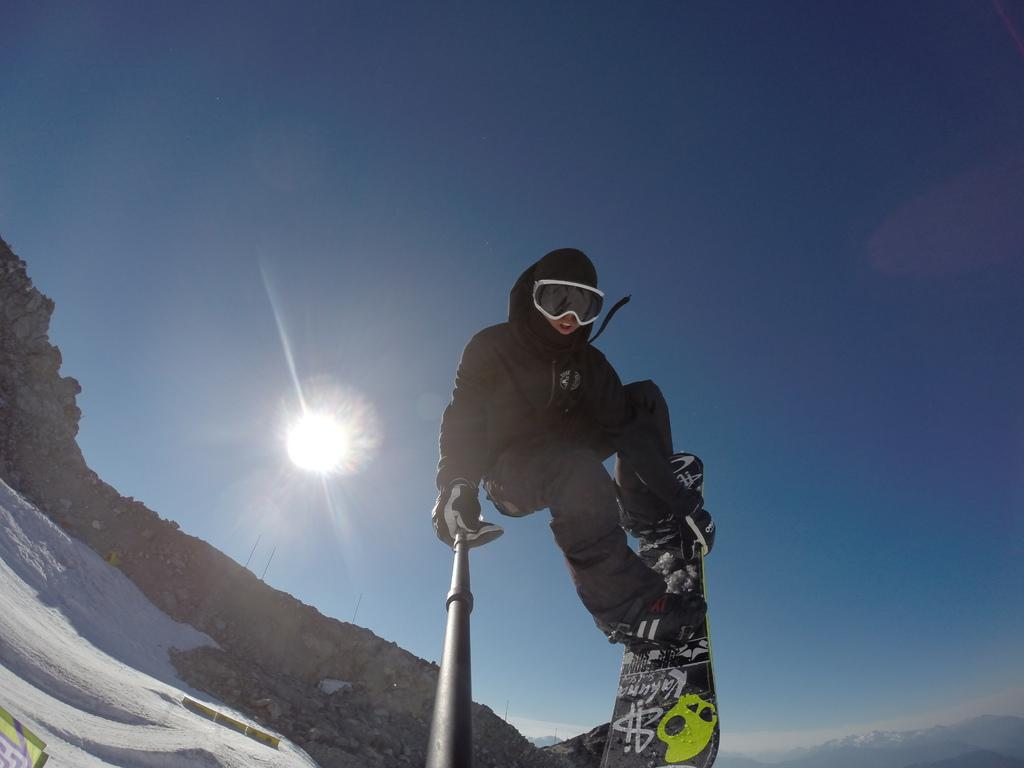What is the person in the image doing? The person is on a ski blade in the image. What is the person holding in their hand? The person is holding an object in their hand. What can be seen in the background of the image? The sun and sky are visible in the background of the image. What type of discussion is taking place between the person and the hose in the image? There is no hose present in the image, and therefore no discussion can be observed. 